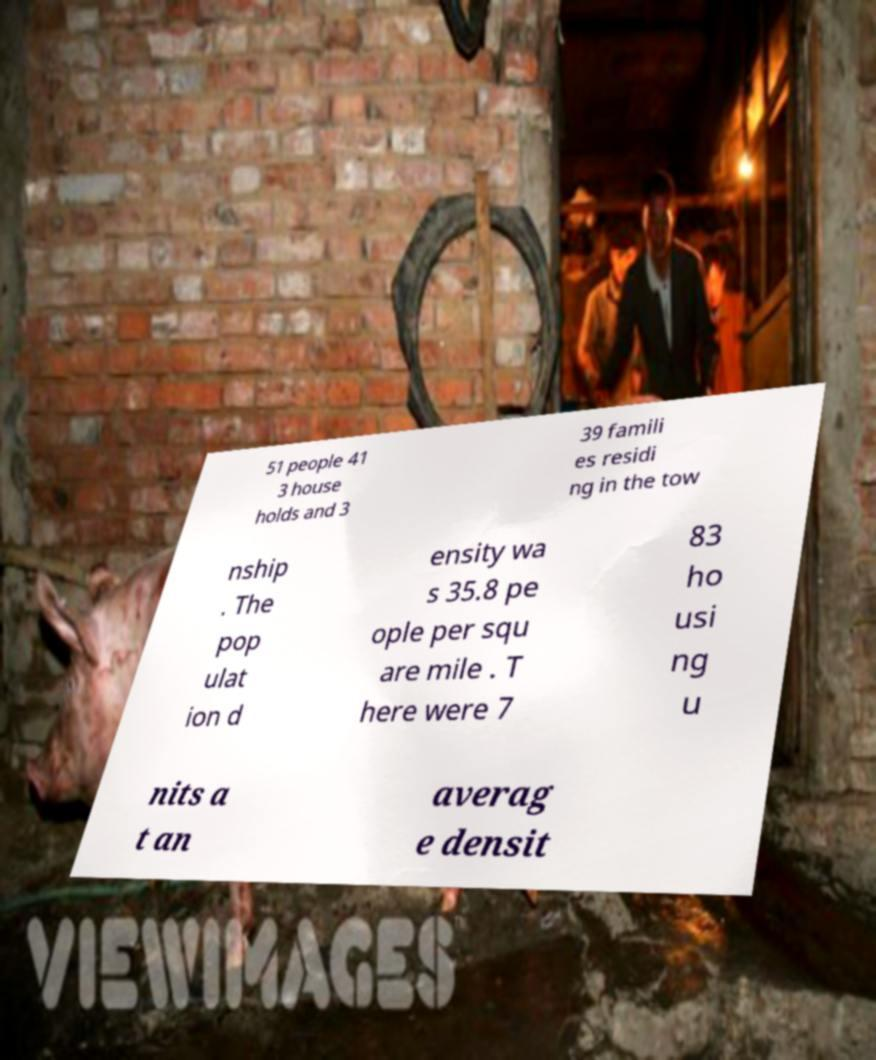Please read and relay the text visible in this image. What does it say? 51 people 41 3 house holds and 3 39 famili es residi ng in the tow nship . The pop ulat ion d ensity wa s 35.8 pe ople per squ are mile . T here were 7 83 ho usi ng u nits a t an averag e densit 